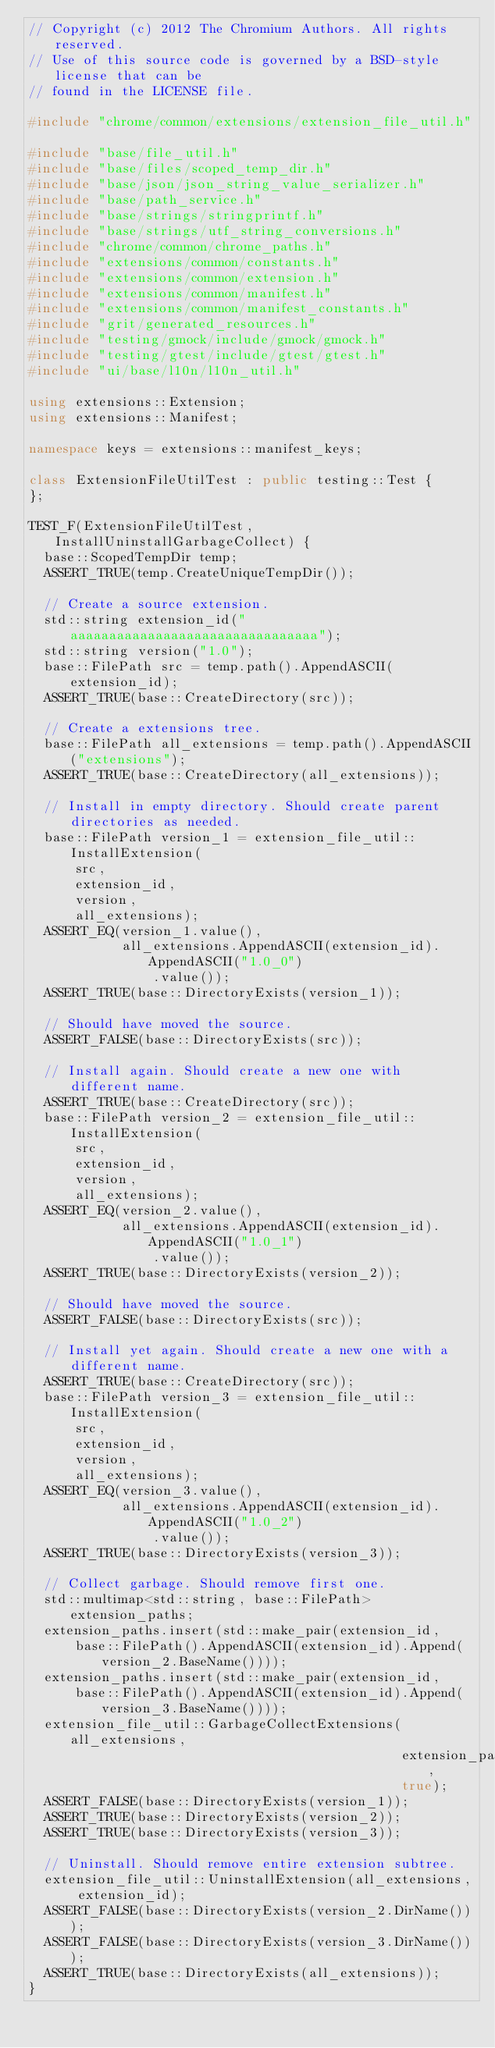<code> <loc_0><loc_0><loc_500><loc_500><_C++_>// Copyright (c) 2012 The Chromium Authors. All rights reserved.
// Use of this source code is governed by a BSD-style license that can be
// found in the LICENSE file.

#include "chrome/common/extensions/extension_file_util.h"

#include "base/file_util.h"
#include "base/files/scoped_temp_dir.h"
#include "base/json/json_string_value_serializer.h"
#include "base/path_service.h"
#include "base/strings/stringprintf.h"
#include "base/strings/utf_string_conversions.h"
#include "chrome/common/chrome_paths.h"
#include "extensions/common/constants.h"
#include "extensions/common/extension.h"
#include "extensions/common/manifest.h"
#include "extensions/common/manifest_constants.h"
#include "grit/generated_resources.h"
#include "testing/gmock/include/gmock/gmock.h"
#include "testing/gtest/include/gtest/gtest.h"
#include "ui/base/l10n/l10n_util.h"

using extensions::Extension;
using extensions::Manifest;

namespace keys = extensions::manifest_keys;

class ExtensionFileUtilTest : public testing::Test {
};

TEST_F(ExtensionFileUtilTest, InstallUninstallGarbageCollect) {
  base::ScopedTempDir temp;
  ASSERT_TRUE(temp.CreateUniqueTempDir());

  // Create a source extension.
  std::string extension_id("aaaaaaaaaaaaaaaaaaaaaaaaaaaaaaaa");
  std::string version("1.0");
  base::FilePath src = temp.path().AppendASCII(extension_id);
  ASSERT_TRUE(base::CreateDirectory(src));

  // Create a extensions tree.
  base::FilePath all_extensions = temp.path().AppendASCII("extensions");
  ASSERT_TRUE(base::CreateDirectory(all_extensions));

  // Install in empty directory. Should create parent directories as needed.
  base::FilePath version_1 = extension_file_util::InstallExtension(
      src,
      extension_id,
      version,
      all_extensions);
  ASSERT_EQ(version_1.value(),
            all_extensions.AppendASCII(extension_id).AppendASCII("1.0_0")
                .value());
  ASSERT_TRUE(base::DirectoryExists(version_1));

  // Should have moved the source.
  ASSERT_FALSE(base::DirectoryExists(src));

  // Install again. Should create a new one with different name.
  ASSERT_TRUE(base::CreateDirectory(src));
  base::FilePath version_2 = extension_file_util::InstallExtension(
      src,
      extension_id,
      version,
      all_extensions);
  ASSERT_EQ(version_2.value(),
            all_extensions.AppendASCII(extension_id).AppendASCII("1.0_1")
                .value());
  ASSERT_TRUE(base::DirectoryExists(version_2));

  // Should have moved the source.
  ASSERT_FALSE(base::DirectoryExists(src));

  // Install yet again. Should create a new one with a different name.
  ASSERT_TRUE(base::CreateDirectory(src));
  base::FilePath version_3 = extension_file_util::InstallExtension(
      src,
      extension_id,
      version,
      all_extensions);
  ASSERT_EQ(version_3.value(),
            all_extensions.AppendASCII(extension_id).AppendASCII("1.0_2")
                .value());
  ASSERT_TRUE(base::DirectoryExists(version_3));

  // Collect garbage. Should remove first one.
  std::multimap<std::string, base::FilePath> extension_paths;
  extension_paths.insert(std::make_pair(extension_id,
      base::FilePath().AppendASCII(extension_id).Append(version_2.BaseName())));
  extension_paths.insert(std::make_pair(extension_id,
      base::FilePath().AppendASCII(extension_id).Append(version_3.BaseName())));
  extension_file_util::GarbageCollectExtensions(all_extensions,
                                                extension_paths,
                                                true);
  ASSERT_FALSE(base::DirectoryExists(version_1));
  ASSERT_TRUE(base::DirectoryExists(version_2));
  ASSERT_TRUE(base::DirectoryExists(version_3));

  // Uninstall. Should remove entire extension subtree.
  extension_file_util::UninstallExtension(all_extensions, extension_id);
  ASSERT_FALSE(base::DirectoryExists(version_2.DirName()));
  ASSERT_FALSE(base::DirectoryExists(version_3.DirName()));
  ASSERT_TRUE(base::DirectoryExists(all_extensions));
}
</code> 